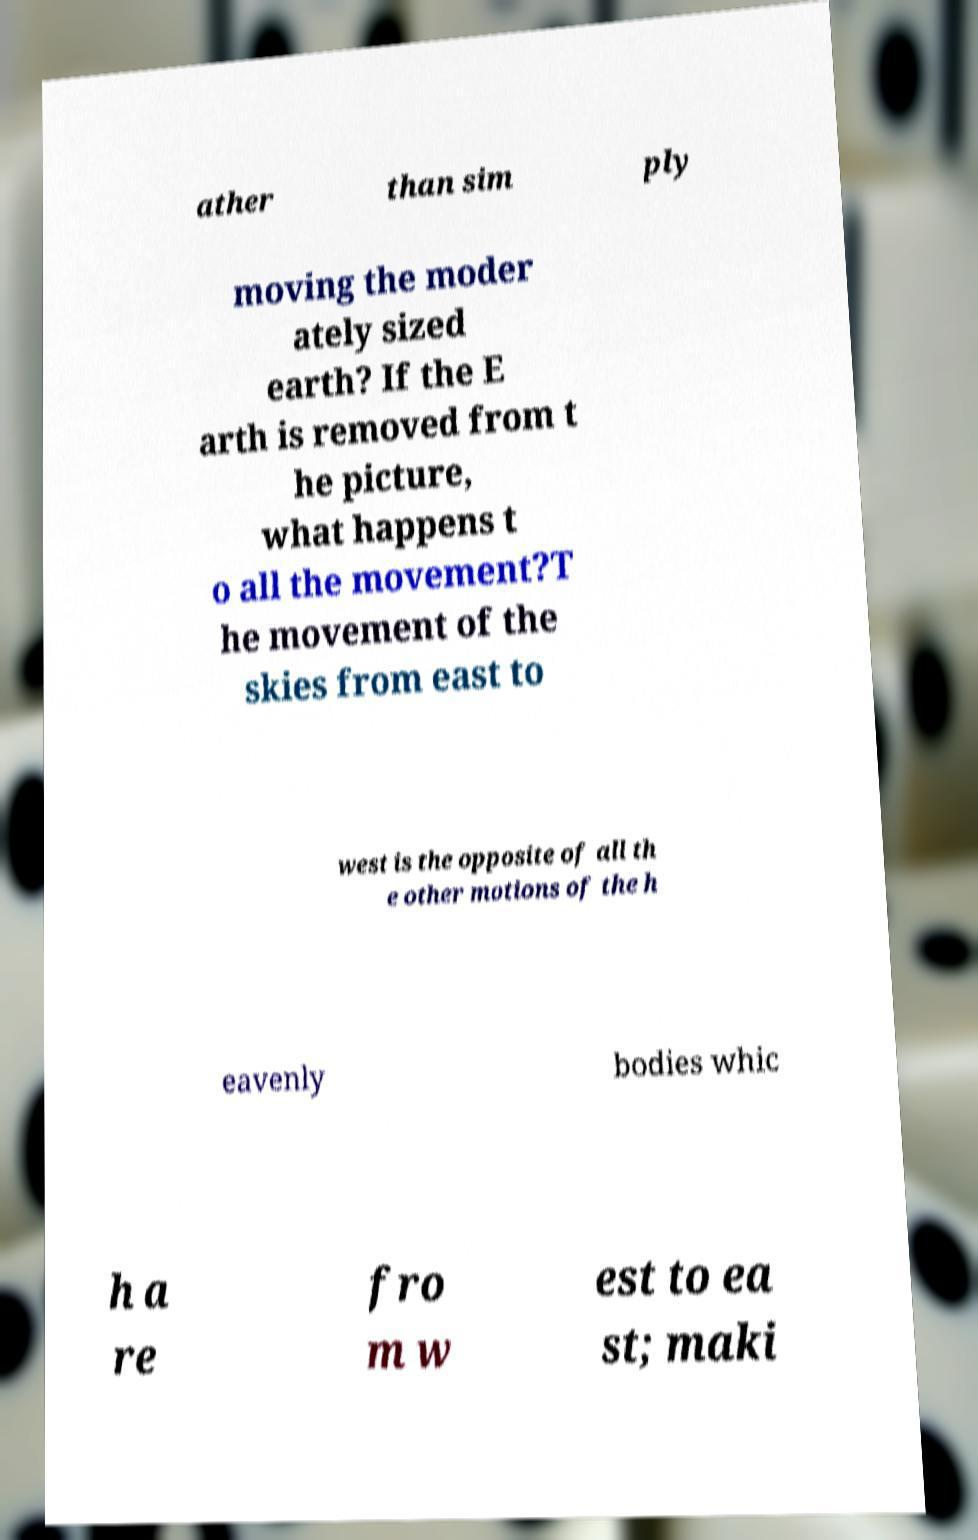Could you assist in decoding the text presented in this image and type it out clearly? ather than sim ply moving the moder ately sized earth? If the E arth is removed from t he picture, what happens t o all the movement?T he movement of the skies from east to west is the opposite of all th e other motions of the h eavenly bodies whic h a re fro m w est to ea st; maki 